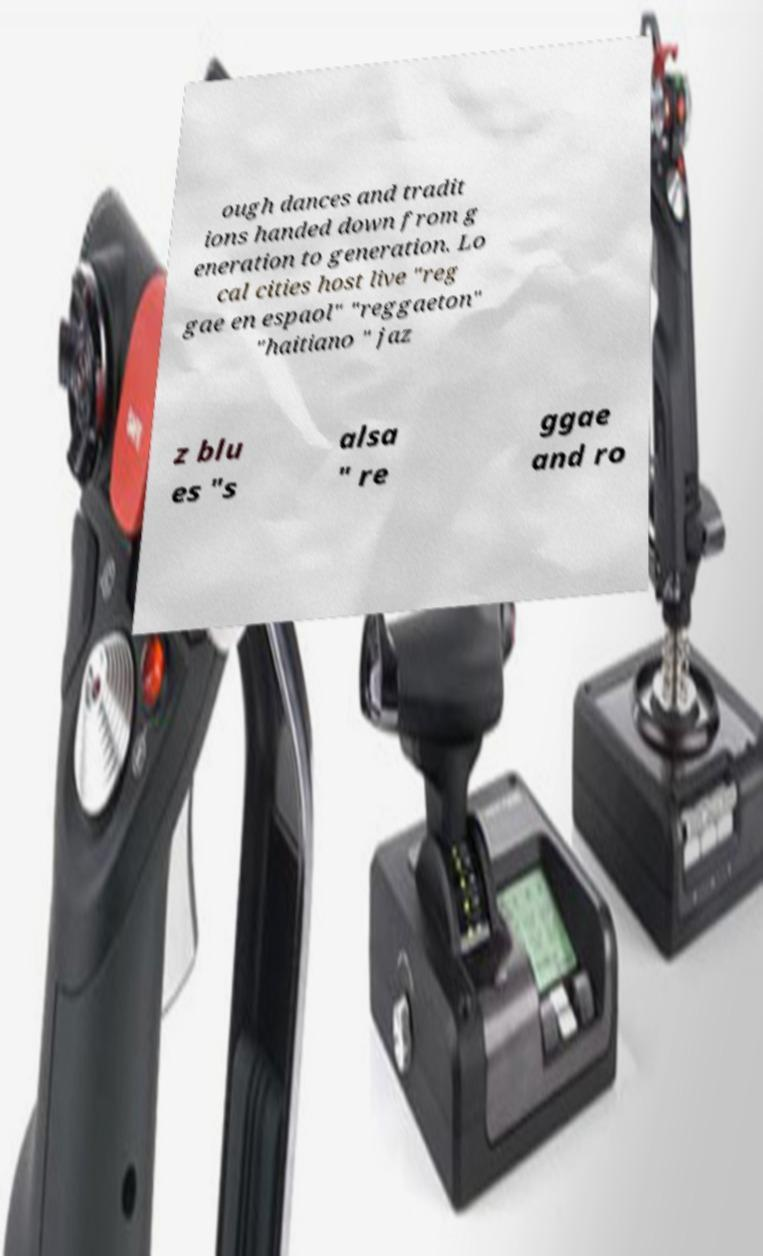I need the written content from this picture converted into text. Can you do that? ough dances and tradit ions handed down from g eneration to generation. Lo cal cities host live "reg gae en espaol" "reggaeton" "haitiano " jaz z blu es "s alsa " re ggae and ro 